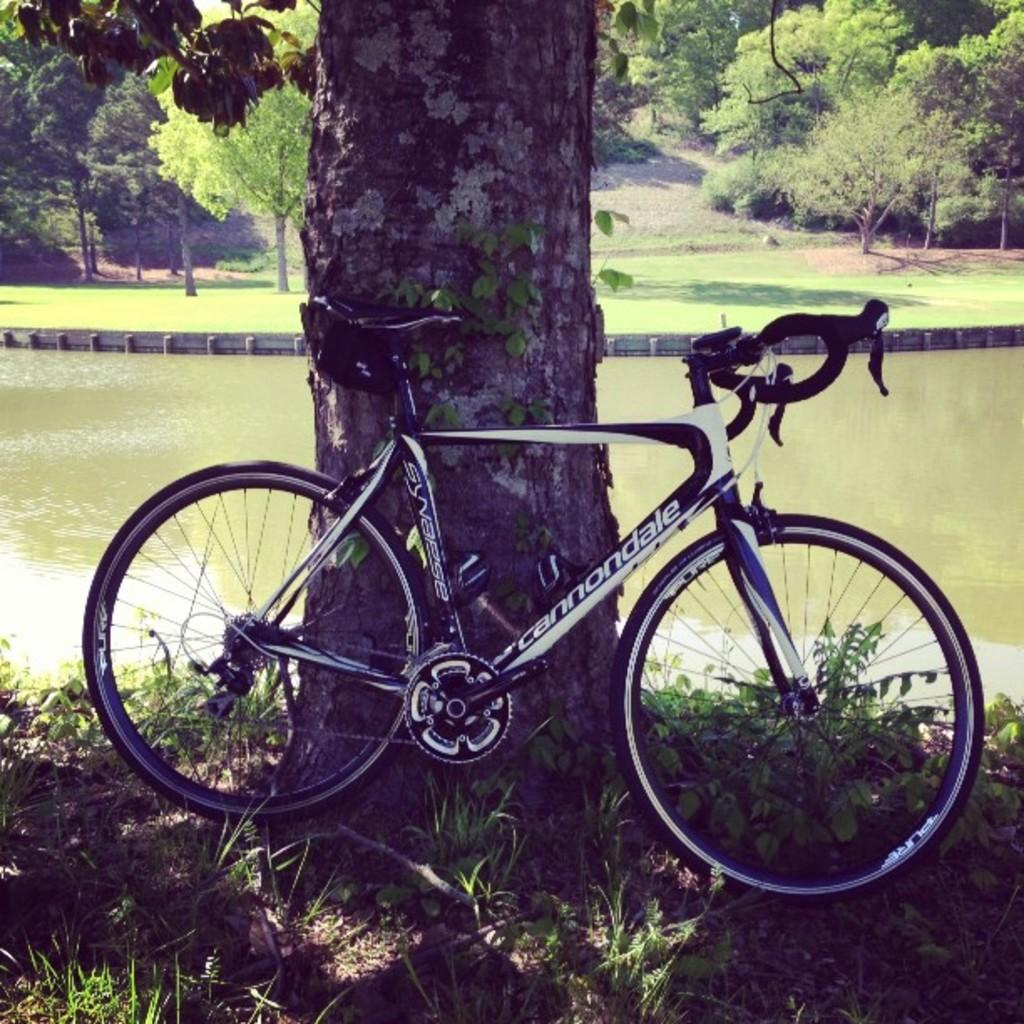What is the main subject of the image? There is a bicycle in the center of the image. Where is the bicycle located? The bicycle is on the grass. What can be seen in the background of the image? There are trees and a lake in the background of the image. What type of ground is visible in the background? The ground is visible in the background of the image. What type of juice is being squeezed from the bicycle in the image? There is no juice or squeezing activity present in the image; it features a bicycle on the grass with a background of trees and a lake. 